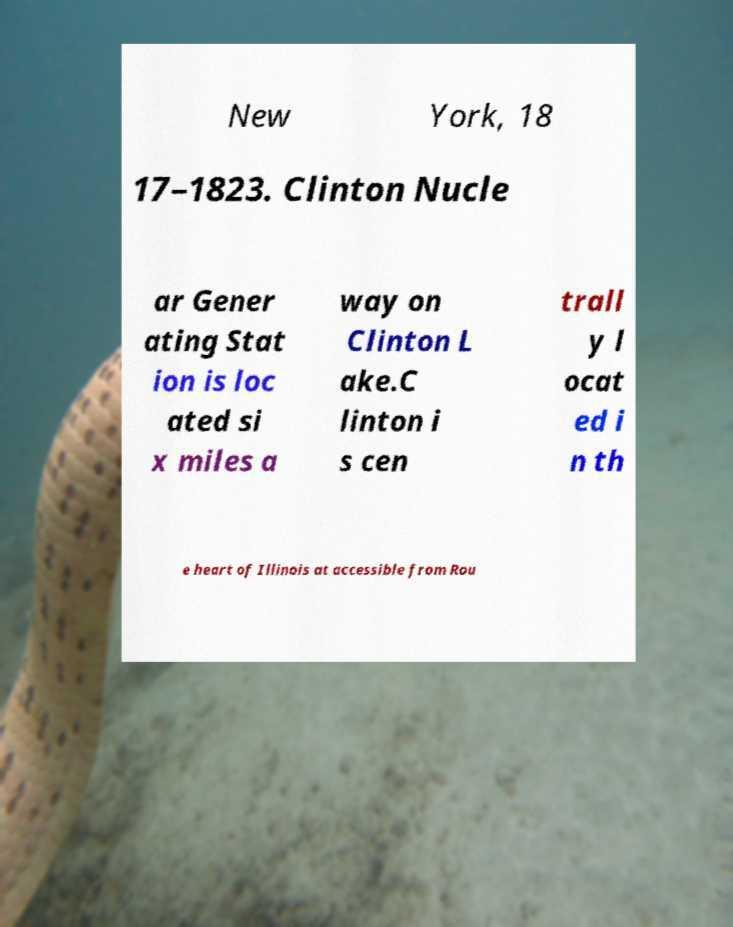Can you read and provide the text displayed in the image?This photo seems to have some interesting text. Can you extract and type it out for me? New York, 18 17–1823. Clinton Nucle ar Gener ating Stat ion is loc ated si x miles a way on Clinton L ake.C linton i s cen trall y l ocat ed i n th e heart of Illinois at accessible from Rou 